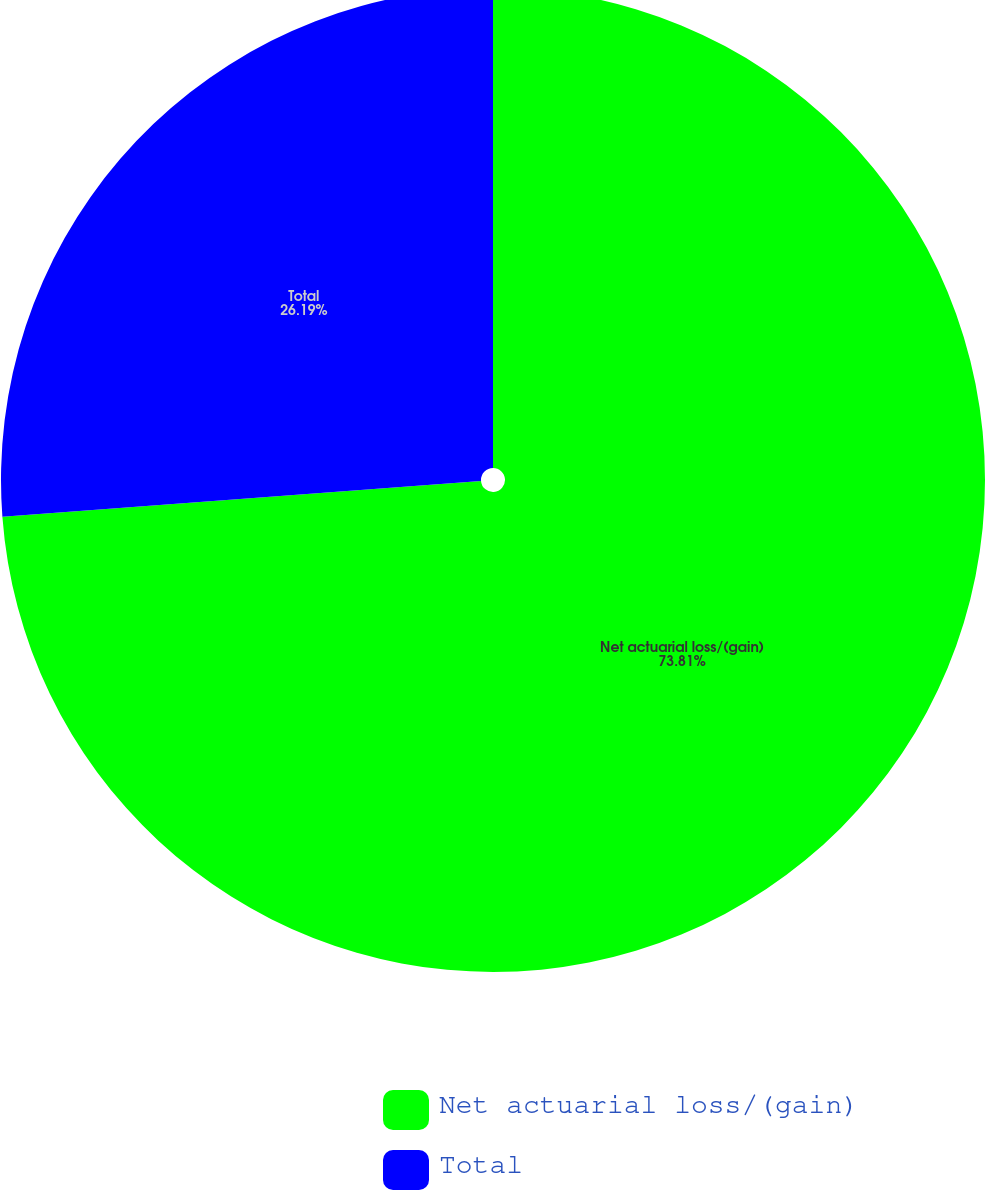Convert chart to OTSL. <chart><loc_0><loc_0><loc_500><loc_500><pie_chart><fcel>Net actuarial loss/(gain)<fcel>Total<nl><fcel>73.81%<fcel>26.19%<nl></chart> 